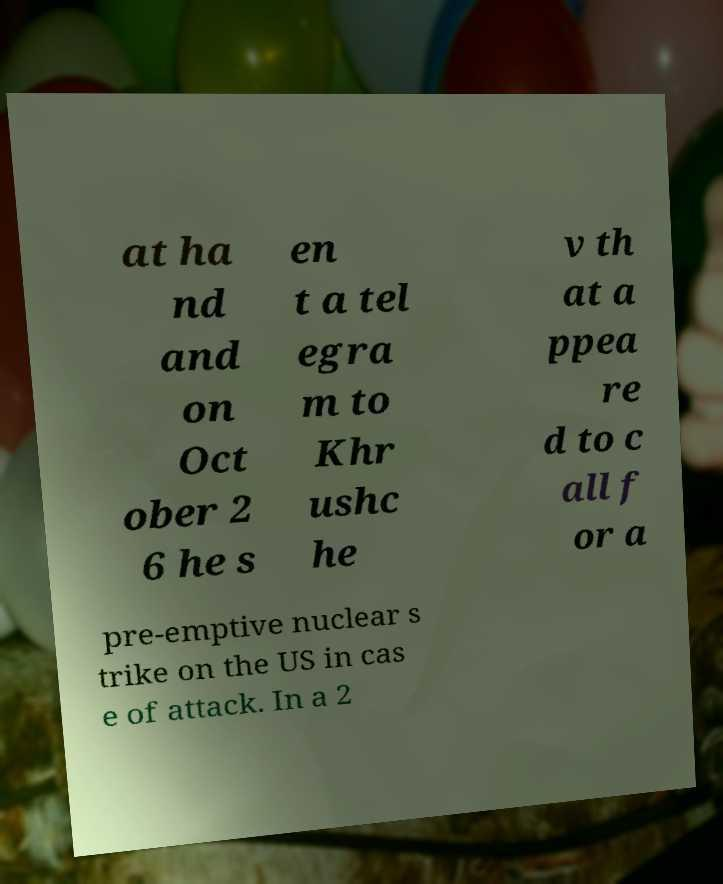There's text embedded in this image that I need extracted. Can you transcribe it verbatim? at ha nd and on Oct ober 2 6 he s en t a tel egra m to Khr ushc he v th at a ppea re d to c all f or a pre-emptive nuclear s trike on the US in cas e of attack. In a 2 